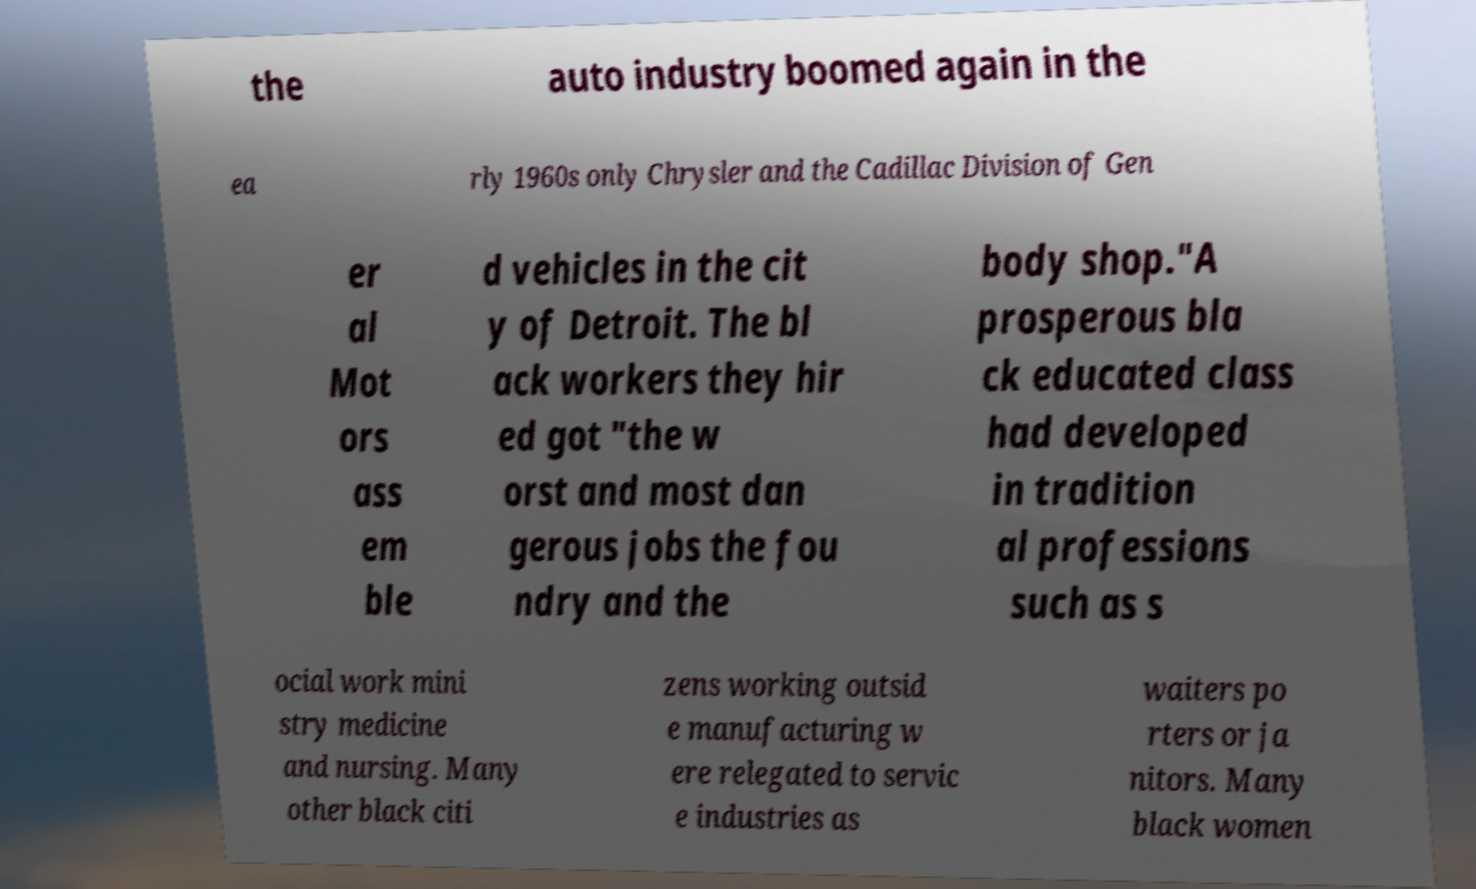Please read and relay the text visible in this image. What does it say? the auto industry boomed again in the ea rly 1960s only Chrysler and the Cadillac Division of Gen er al Mot ors ass em ble d vehicles in the cit y of Detroit. The bl ack workers they hir ed got "the w orst and most dan gerous jobs the fou ndry and the body shop."A prosperous bla ck educated class had developed in tradition al professions such as s ocial work mini stry medicine and nursing. Many other black citi zens working outsid e manufacturing w ere relegated to servic e industries as waiters po rters or ja nitors. Many black women 